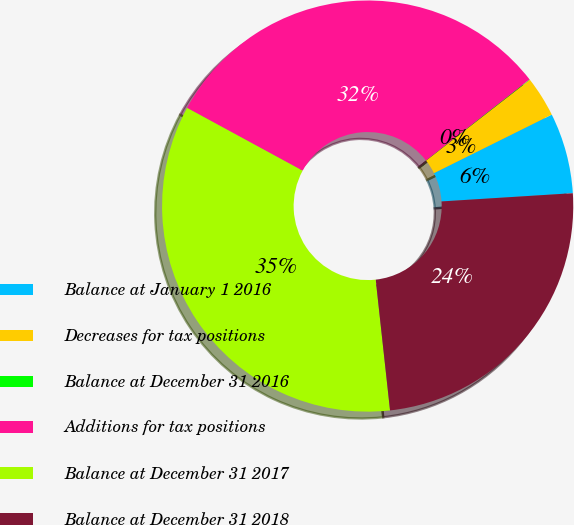<chart> <loc_0><loc_0><loc_500><loc_500><pie_chart><fcel>Balance at January 1 2016<fcel>Decreases for tax positions<fcel>Balance at December 31 2016<fcel>Additions for tax positions<fcel>Balance at December 31 2017<fcel>Balance at December 31 2018<nl><fcel>6.34%<fcel>3.19%<fcel>0.04%<fcel>31.51%<fcel>34.66%<fcel>24.26%<nl></chart> 